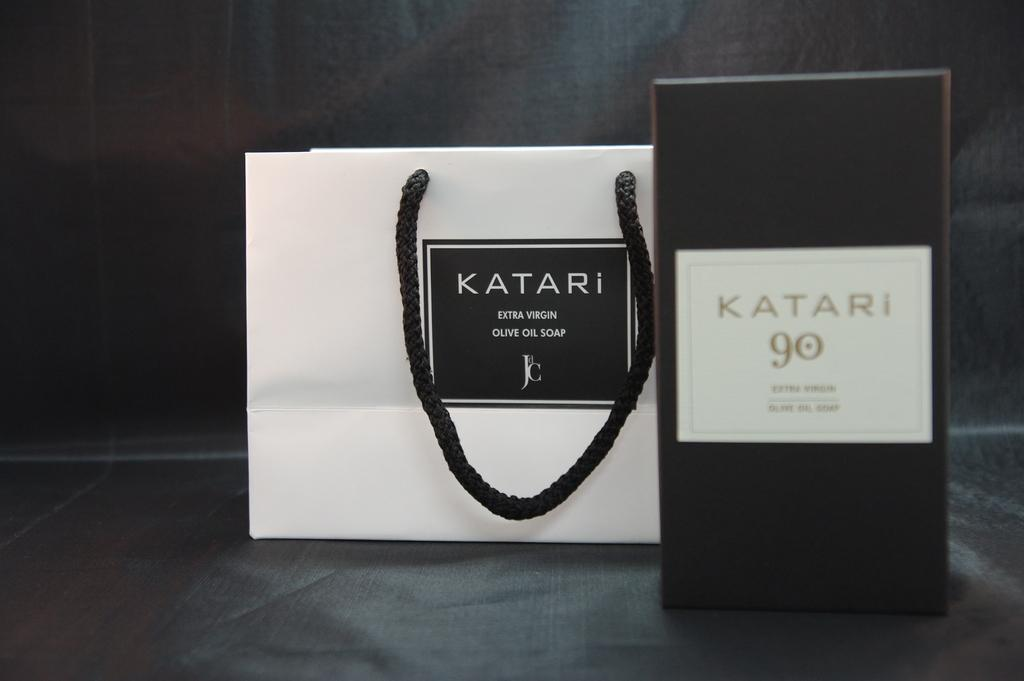What objects are present in the image? There is a bag and a box in the image. What can be found on the surfaces of the objects? There is writing on both the box and the bag. What color is the background of the image? The background of the image is black. What type of street is visible in the image? There is no street visible in the image; it only contains a bag, a box, and writing on their surfaces against a black background. Is there a van present in the image? There is no van present in the image. 